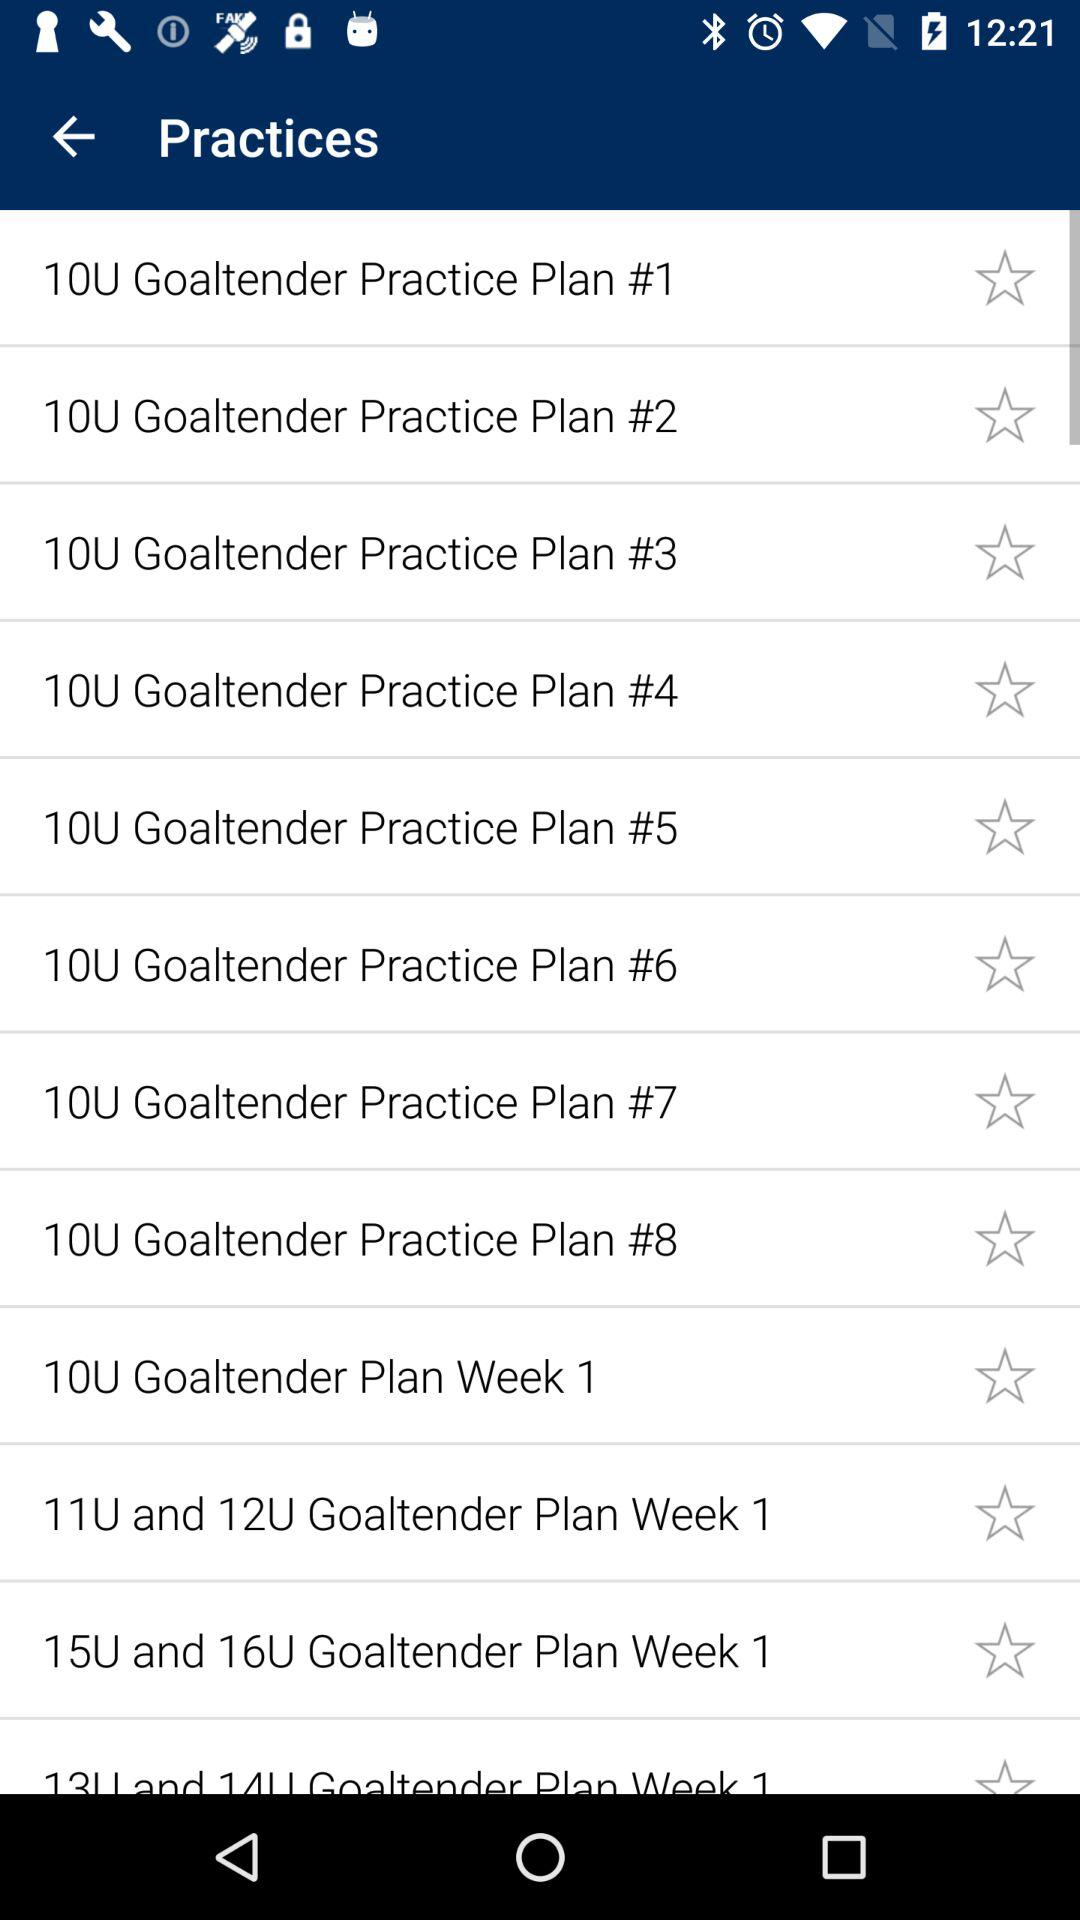How many practice plans are there for 10U goaltenders?
Answer the question using a single word or phrase. 8 